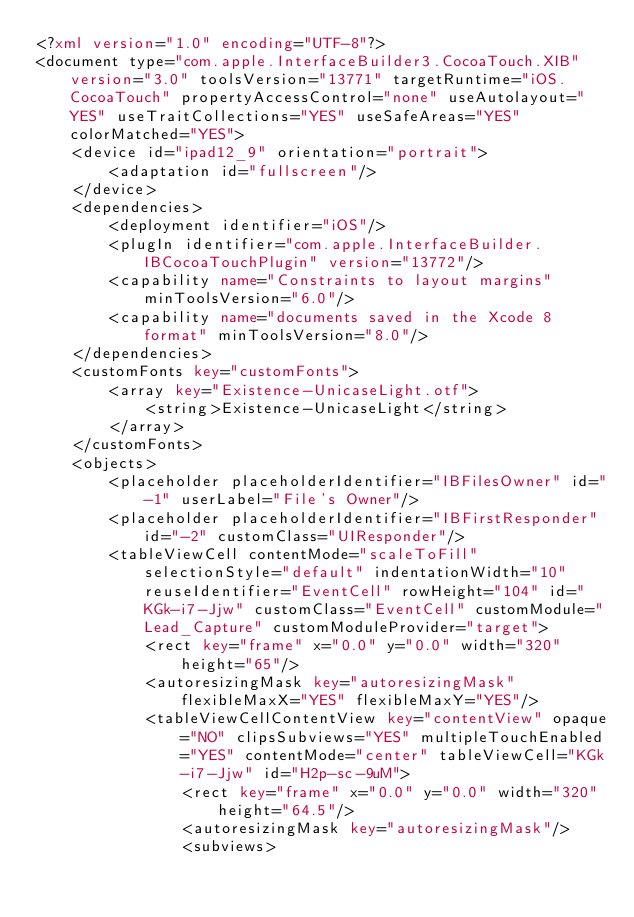Convert code to text. <code><loc_0><loc_0><loc_500><loc_500><_XML_><?xml version="1.0" encoding="UTF-8"?>
<document type="com.apple.InterfaceBuilder3.CocoaTouch.XIB" version="3.0" toolsVersion="13771" targetRuntime="iOS.CocoaTouch" propertyAccessControl="none" useAutolayout="YES" useTraitCollections="YES" useSafeAreas="YES" colorMatched="YES">
    <device id="ipad12_9" orientation="portrait">
        <adaptation id="fullscreen"/>
    </device>
    <dependencies>
        <deployment identifier="iOS"/>
        <plugIn identifier="com.apple.InterfaceBuilder.IBCocoaTouchPlugin" version="13772"/>
        <capability name="Constraints to layout margins" minToolsVersion="6.0"/>
        <capability name="documents saved in the Xcode 8 format" minToolsVersion="8.0"/>
    </dependencies>
    <customFonts key="customFonts">
        <array key="Existence-UnicaseLight.otf">
            <string>Existence-UnicaseLight</string>
        </array>
    </customFonts>
    <objects>
        <placeholder placeholderIdentifier="IBFilesOwner" id="-1" userLabel="File's Owner"/>
        <placeholder placeholderIdentifier="IBFirstResponder" id="-2" customClass="UIResponder"/>
        <tableViewCell contentMode="scaleToFill" selectionStyle="default" indentationWidth="10" reuseIdentifier="EventCell" rowHeight="104" id="KGk-i7-Jjw" customClass="EventCell" customModule="Lead_Capture" customModuleProvider="target">
            <rect key="frame" x="0.0" y="0.0" width="320" height="65"/>
            <autoresizingMask key="autoresizingMask" flexibleMaxX="YES" flexibleMaxY="YES"/>
            <tableViewCellContentView key="contentView" opaque="NO" clipsSubviews="YES" multipleTouchEnabled="YES" contentMode="center" tableViewCell="KGk-i7-Jjw" id="H2p-sc-9uM">
                <rect key="frame" x="0.0" y="0.0" width="320" height="64.5"/>
                <autoresizingMask key="autoresizingMask"/>
                <subviews></code> 